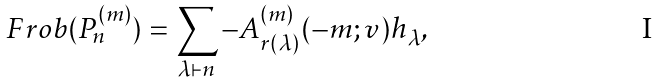Convert formula to latex. <formula><loc_0><loc_0><loc_500><loc_500>F r o b ( P ^ { ( m ) } _ { n } ) = \sum _ { \lambda \vdash n } - A ^ { ( m ) } _ { r ( \lambda ) } ( - m ; v ) h _ { \lambda } ,</formula> 